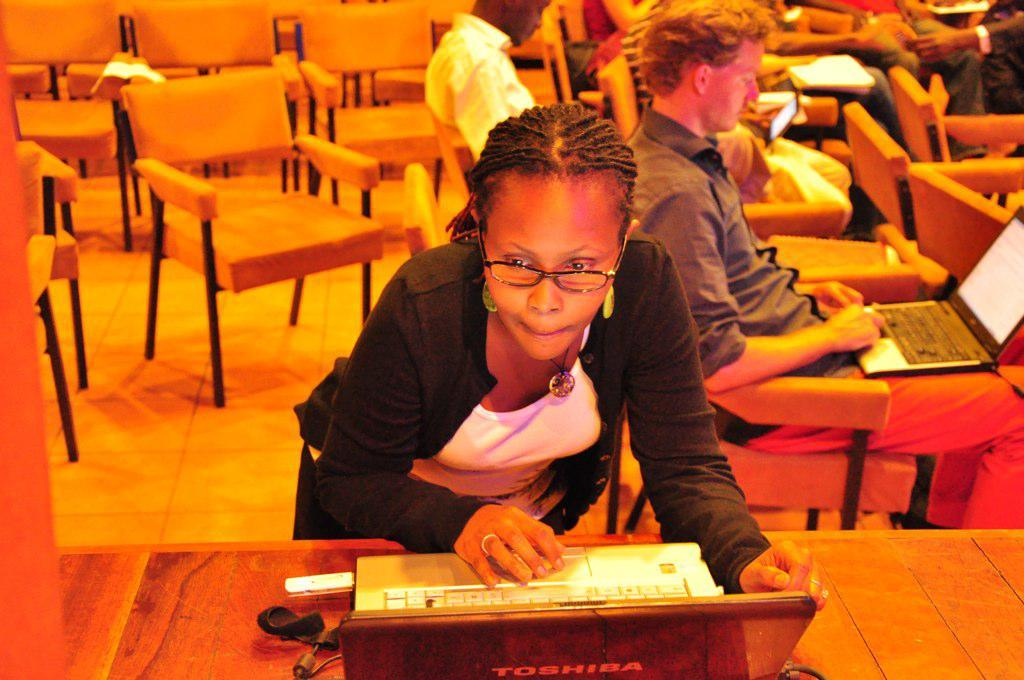How many people can be seen in the image working in the image? There are many people in the image. What are the people doing in the image? The people are working on laptops. Can you identify the brand of the laptops in the image? Yes, the laptop has "Toshiba" written on it. What type of furniture is present in the image? There are many chairs in the image. What type of grain is being harvested in the image? There is no grain or harvesting activity present in the image. How many wrens can be seen flying in the image? There are no wrens or flying birds present in the image. 